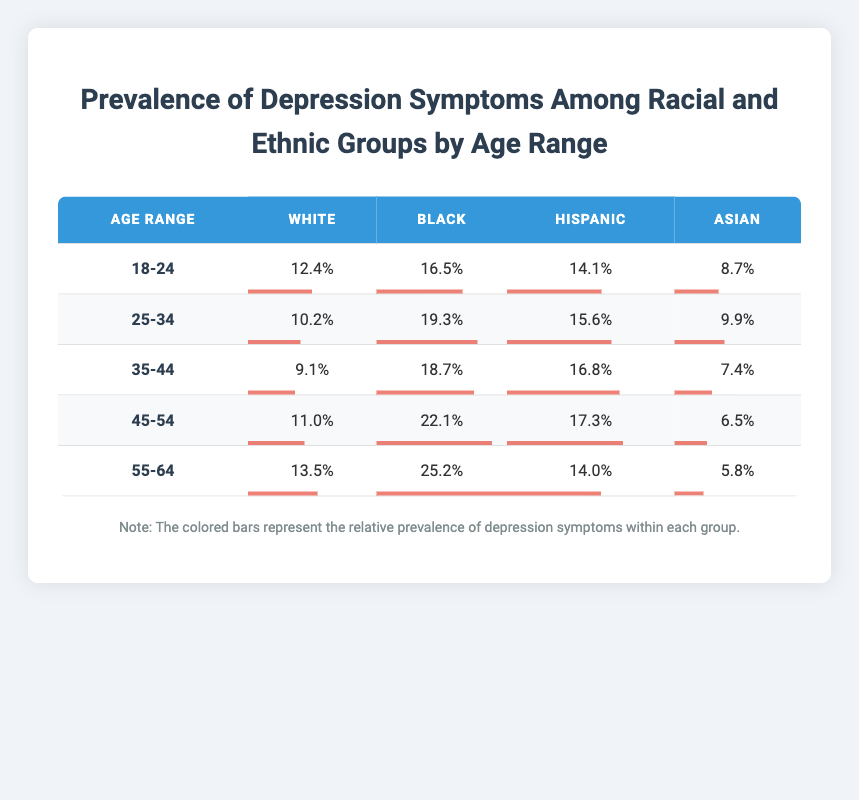What is the prevalence percentage of depression symptoms among Black individuals aged 25-34? Looking at the table, under the age range 25-34 and the race/ethnicity category Black, the prevalence percentage is 19.3%.
Answer: 19.3% Which age group has the highest prevalence of depression symptoms among Hispanic individuals? To find the highest prevalence among Hispanic individuals, I look at each age range: 14.1% (18-24), 15.6% (25-34), 16.8% (35-44), 17.3% (45-54), and 14.0% (55-64). The highest is 17.3% for the age range 45-54.
Answer: 45-54 Is the prevalence of depression symptoms among Asians higher in the age range 35-44 compared to 55-64? In the table, the prevalence for Asians aged 35-44 is 7.4%, whereas for those aged 55-64 it is 5.8%. Since 7.4% is greater than 5.8%, the statement is true.
Answer: Yes What is the difference in prevalence percentages of depression symptoms between White individuals aged 18-24 and those aged 45-54? The prevalence for White individuals aged 18-24 is 12.4%, and for those aged 45-54, it is 11.0%. The difference is 12.4% - 11.0% which equals 1.4%.
Answer: 1.4% Which racial or ethnic group has the lowest overall prevalence of depression symptoms across all age ranges? Reviewing the table for all age ranges, the lowest prevalence percentage across all groups is found among Asians, which is 5.8% at the age range 55-64.
Answer: Asian What is the average prevalence percentage for Black individuals across all age ranges? To calculate the average for Black individuals, I add the prevalence percentages: 16.5% (18-24) + 19.3% (25-34) + 18.7% (35-44) + 22.1% (45-54) + 25.2% (55-64) = 101.8%. Then divide by 5, yielding 20.36%.
Answer: 20.36% Which group has a higher prevalence percentage of depression symptoms: Black individuals aged 55-64 or Hispanic individuals aged 25-34? Checking the table, the prevalence for Black individuals aged 55-64 is 25.2%, while for Hispanic individuals aged 25-34 it is 15.6%. Since 25.2% is greater than 15.6%, Black individuals aged 55-64 have a higher percentage.
Answer: Black individuals aged 55-64 Is the prevalence of depression symptoms among Hispanic individuals aged 35-44 less than that of White individuals in the same age range? The prevalence for Hispanic individuals aged 35-44 is 16.8%, whereas for White individuals it is 9.1%. Since 16.8% is greater than 9.1%, the statement is false.
Answer: No 